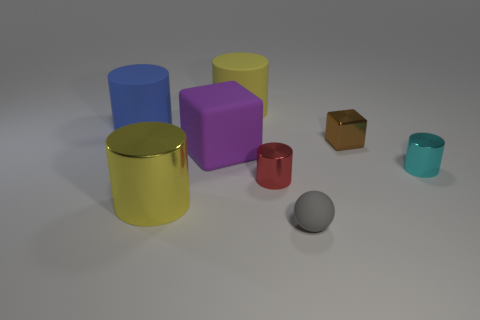Subtract all big blue cylinders. How many cylinders are left? 4 Subtract all yellow spheres. How many yellow cylinders are left? 2 Subtract all yellow cylinders. How many cylinders are left? 3 Subtract 3 cylinders. How many cylinders are left? 2 Add 2 big shiny cylinders. How many objects exist? 10 Subtract all cylinders. How many objects are left? 3 Subtract 0 cyan balls. How many objects are left? 8 Subtract all green cylinders. Subtract all green spheres. How many cylinders are left? 5 Subtract all big blue matte blocks. Subtract all large shiny things. How many objects are left? 7 Add 5 red shiny objects. How many red shiny objects are left? 6 